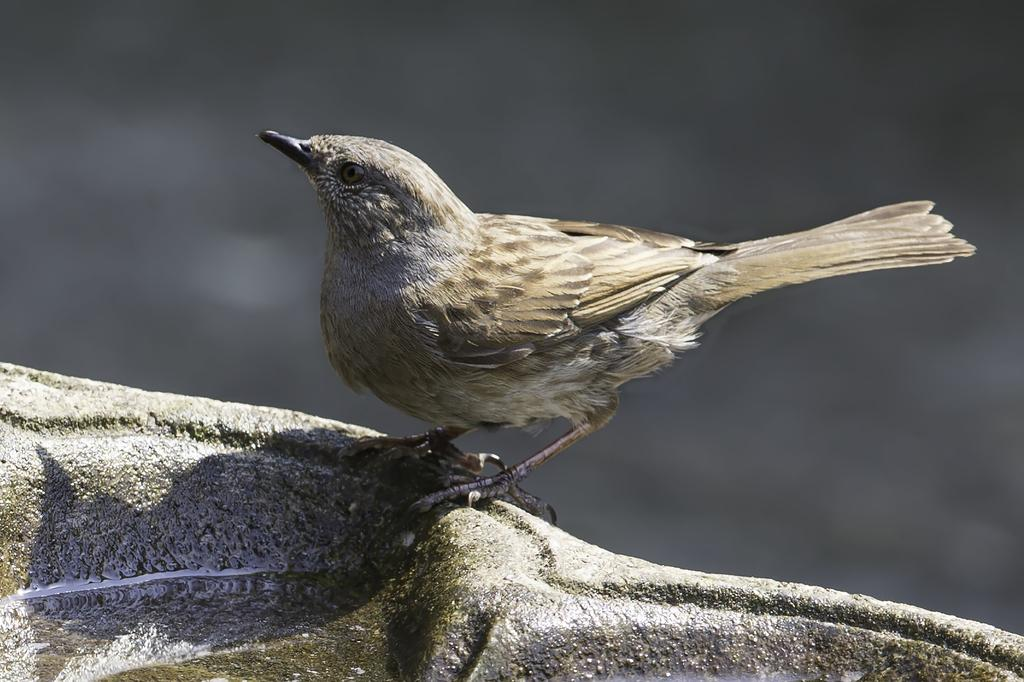What type of animal is standing in the image? There is a bird standing in the image. What is the bird standing on? The bird is standing on a rock in the image. Is there any water present in the image? Yes, there is water on a rock in the image. What type of yard can be seen in the background of the image? There is no yard visible in the image; it only shows a bird standing on a rock with water. 